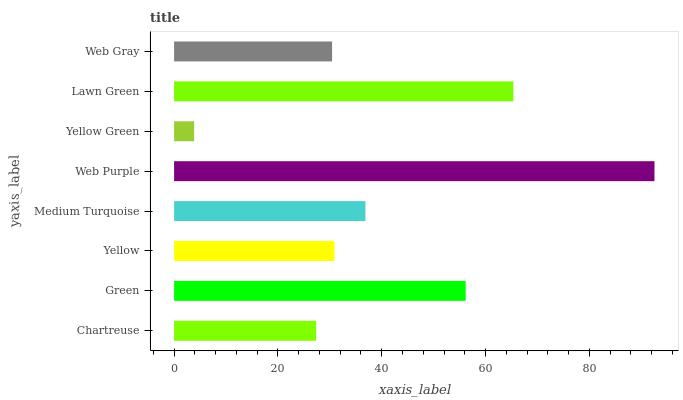Is Yellow Green the minimum?
Answer yes or no. Yes. Is Web Purple the maximum?
Answer yes or no. Yes. Is Green the minimum?
Answer yes or no. No. Is Green the maximum?
Answer yes or no. No. Is Green greater than Chartreuse?
Answer yes or no. Yes. Is Chartreuse less than Green?
Answer yes or no. Yes. Is Chartreuse greater than Green?
Answer yes or no. No. Is Green less than Chartreuse?
Answer yes or no. No. Is Medium Turquoise the high median?
Answer yes or no. Yes. Is Yellow the low median?
Answer yes or no. Yes. Is Lawn Green the high median?
Answer yes or no. No. Is Yellow Green the low median?
Answer yes or no. No. 